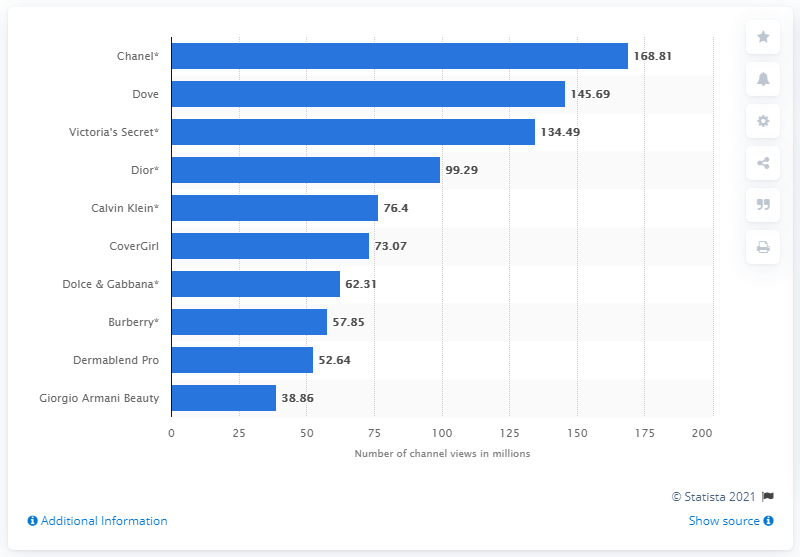Mention a couple of crucial points in this snapshot. During the survey period, Dove had a total of 145.69 channel views. According to the survey, a beauty brand named Dove had 145.69 million channel views during the survey period. 